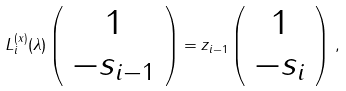<formula> <loc_0><loc_0><loc_500><loc_500>L ^ { ( x ) } _ { i } ( \lambda ) \left ( \begin{array} { c } 1 \\ - s _ { i - 1 } \end{array} \right ) = z _ { i - 1 } \left ( \begin{array} { c } 1 \\ - s _ { i } \end{array} \right ) \, ,</formula> 